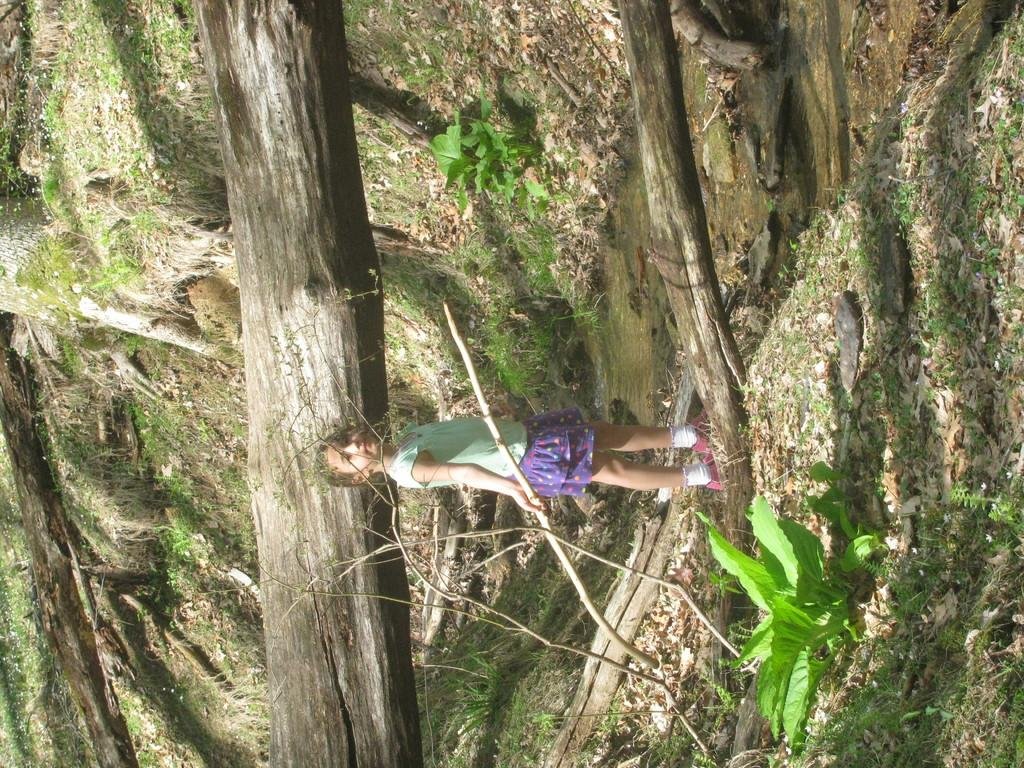Who is the main subject in the image? There is a girl standing in the middle of the image. What is the girl holding in the image? The girl is holding a stick. What type of terrain is visible at the bottom of the image? There is grass at the bottom of the image. What type of vegetation is present in the image? There are plants, stems, and trees visible in the image. What rhythm is the boy dancing to in the image? There is no boy present in the image, and therefore no dancing or rhythm can be observed. 